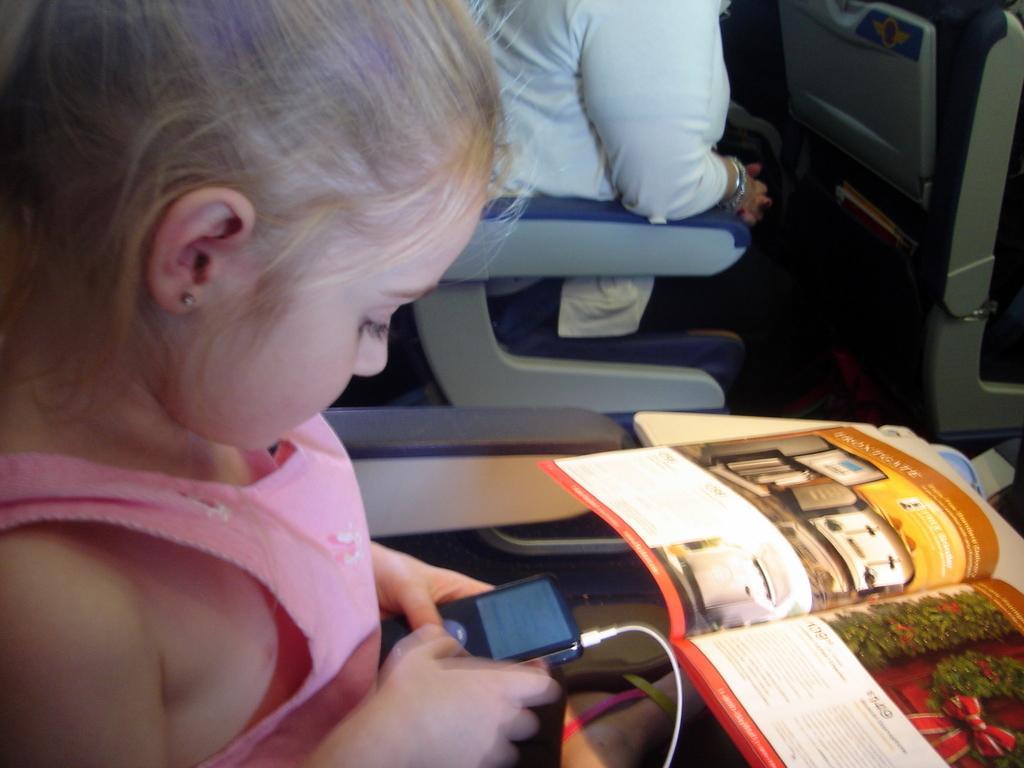Can you describe this image briefly? In the image a girl is sitting in the vehicle and holding a electronic device and there is a book. Behind the girl a person is sitting in the vehicle. 